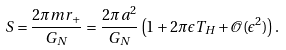Convert formula to latex. <formula><loc_0><loc_0><loc_500><loc_500>S = \frac { 2 \pi m r _ { + } } { G _ { N } } = \frac { 2 \pi a ^ { 2 } } { G _ { N } } \left ( 1 + 2 \pi \epsilon T _ { H } + \mathcal { O } ( \epsilon ^ { 2 } ) \right ) .</formula> 